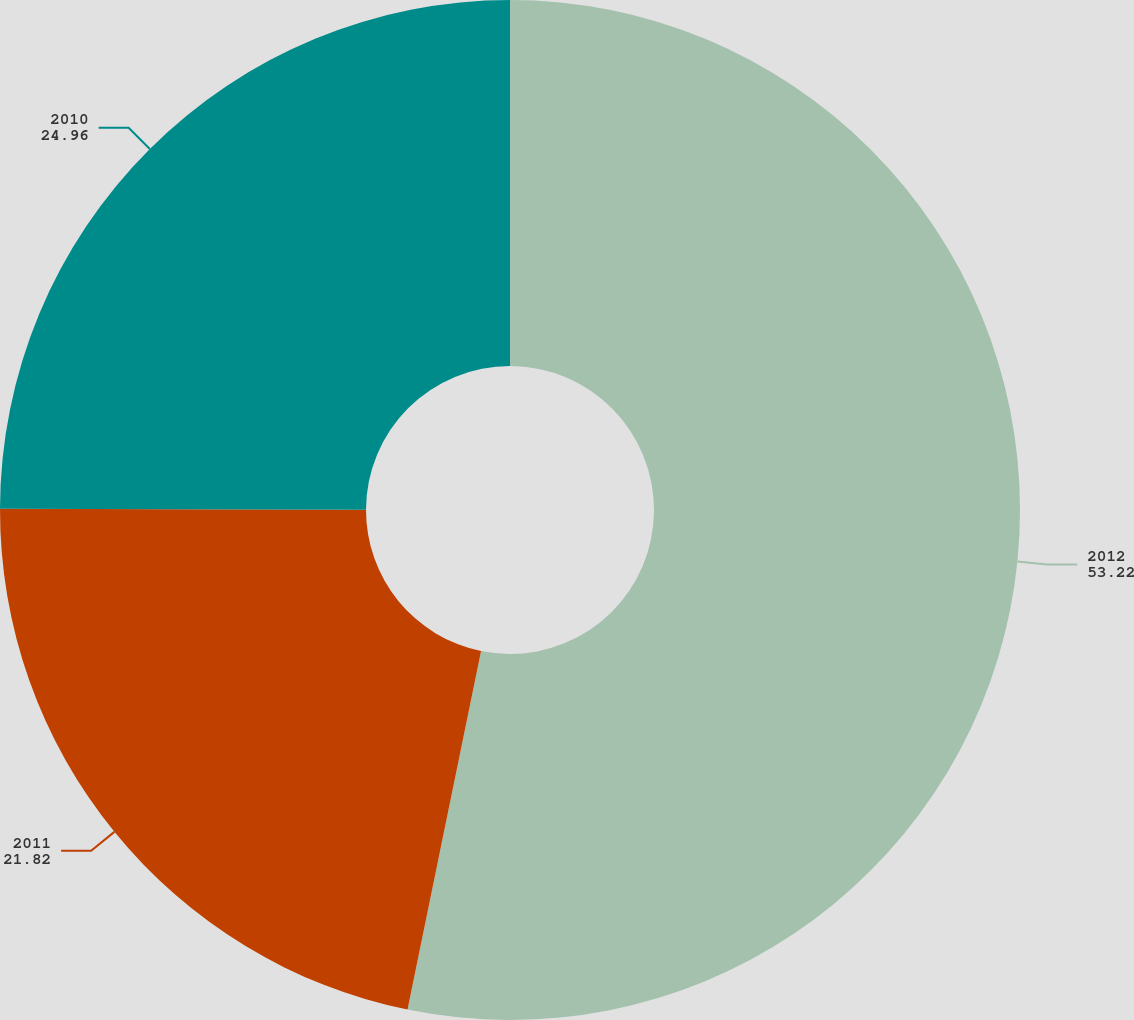Convert chart. <chart><loc_0><loc_0><loc_500><loc_500><pie_chart><fcel>2012<fcel>2011<fcel>2010<nl><fcel>53.22%<fcel>21.82%<fcel>24.96%<nl></chart> 